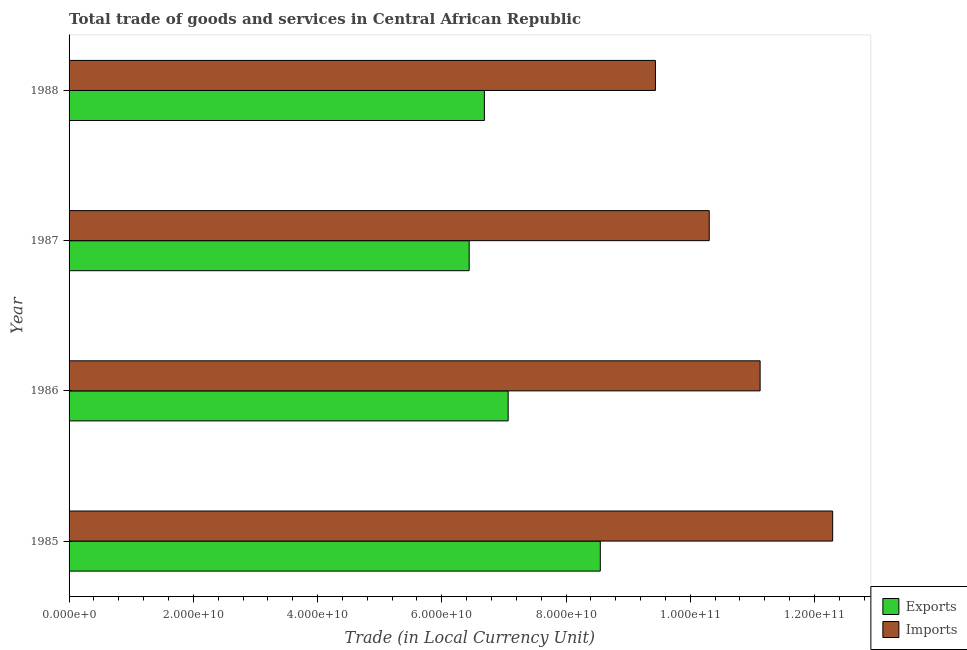How many different coloured bars are there?
Provide a short and direct response. 2. How many groups of bars are there?
Give a very brief answer. 4. How many bars are there on the 1st tick from the top?
Make the answer very short. 2. What is the label of the 1st group of bars from the top?
Your response must be concise. 1988. In how many cases, is the number of bars for a given year not equal to the number of legend labels?
Offer a very short reply. 0. What is the imports of goods and services in 1986?
Keep it short and to the point. 1.11e+11. Across all years, what is the maximum imports of goods and services?
Give a very brief answer. 1.23e+11. Across all years, what is the minimum export of goods and services?
Your response must be concise. 6.44e+1. In which year was the imports of goods and services minimum?
Your response must be concise. 1988. What is the total imports of goods and services in the graph?
Your answer should be compact. 4.32e+11. What is the difference between the imports of goods and services in 1985 and that in 1988?
Your answer should be very brief. 2.85e+1. What is the difference between the imports of goods and services in 1986 and the export of goods and services in 1985?
Provide a succinct answer. 2.57e+1. What is the average imports of goods and services per year?
Ensure brevity in your answer.  1.08e+11. In the year 1987, what is the difference between the export of goods and services and imports of goods and services?
Offer a terse response. -3.86e+1. In how many years, is the imports of goods and services greater than 24000000000 LCU?
Make the answer very short. 4. Is the export of goods and services in 1985 less than that in 1988?
Offer a terse response. No. What is the difference between the highest and the second highest imports of goods and services?
Your response must be concise. 1.17e+1. What is the difference between the highest and the lowest imports of goods and services?
Ensure brevity in your answer.  2.85e+1. In how many years, is the imports of goods and services greater than the average imports of goods and services taken over all years?
Your answer should be very brief. 2. What does the 1st bar from the top in 1987 represents?
Give a very brief answer. Imports. What does the 2nd bar from the bottom in 1988 represents?
Ensure brevity in your answer.  Imports. How many bars are there?
Your answer should be compact. 8. What is the difference between two consecutive major ticks on the X-axis?
Make the answer very short. 2.00e+1. Does the graph contain grids?
Offer a very short reply. No. How many legend labels are there?
Your response must be concise. 2. What is the title of the graph?
Keep it short and to the point. Total trade of goods and services in Central African Republic. Does "Lower secondary rate" appear as one of the legend labels in the graph?
Ensure brevity in your answer.  No. What is the label or title of the X-axis?
Give a very brief answer. Trade (in Local Currency Unit). What is the label or title of the Y-axis?
Your answer should be compact. Year. What is the Trade (in Local Currency Unit) of Exports in 1985?
Offer a terse response. 8.55e+1. What is the Trade (in Local Currency Unit) of Imports in 1985?
Provide a short and direct response. 1.23e+11. What is the Trade (in Local Currency Unit) in Exports in 1986?
Offer a very short reply. 7.07e+1. What is the Trade (in Local Currency Unit) of Imports in 1986?
Offer a very short reply. 1.11e+11. What is the Trade (in Local Currency Unit) of Exports in 1987?
Your answer should be very brief. 6.44e+1. What is the Trade (in Local Currency Unit) of Imports in 1987?
Offer a terse response. 1.03e+11. What is the Trade (in Local Currency Unit) in Exports in 1988?
Keep it short and to the point. 6.69e+1. What is the Trade (in Local Currency Unit) in Imports in 1988?
Make the answer very short. 9.44e+1. Across all years, what is the maximum Trade (in Local Currency Unit) in Exports?
Offer a terse response. 8.55e+1. Across all years, what is the maximum Trade (in Local Currency Unit) of Imports?
Give a very brief answer. 1.23e+11. Across all years, what is the minimum Trade (in Local Currency Unit) in Exports?
Offer a terse response. 6.44e+1. Across all years, what is the minimum Trade (in Local Currency Unit) of Imports?
Provide a short and direct response. 9.44e+1. What is the total Trade (in Local Currency Unit) in Exports in the graph?
Keep it short and to the point. 2.87e+11. What is the total Trade (in Local Currency Unit) of Imports in the graph?
Your answer should be compact. 4.32e+11. What is the difference between the Trade (in Local Currency Unit) of Exports in 1985 and that in 1986?
Offer a terse response. 1.48e+1. What is the difference between the Trade (in Local Currency Unit) in Imports in 1985 and that in 1986?
Your answer should be very brief. 1.17e+1. What is the difference between the Trade (in Local Currency Unit) in Exports in 1985 and that in 1987?
Make the answer very short. 2.11e+1. What is the difference between the Trade (in Local Currency Unit) in Imports in 1985 and that in 1987?
Give a very brief answer. 1.99e+1. What is the difference between the Trade (in Local Currency Unit) in Exports in 1985 and that in 1988?
Provide a succinct answer. 1.87e+1. What is the difference between the Trade (in Local Currency Unit) of Imports in 1985 and that in 1988?
Your answer should be very brief. 2.85e+1. What is the difference between the Trade (in Local Currency Unit) in Exports in 1986 and that in 1987?
Ensure brevity in your answer.  6.27e+09. What is the difference between the Trade (in Local Currency Unit) of Imports in 1986 and that in 1987?
Provide a succinct answer. 8.19e+09. What is the difference between the Trade (in Local Currency Unit) of Exports in 1986 and that in 1988?
Your answer should be very brief. 3.83e+09. What is the difference between the Trade (in Local Currency Unit) of Imports in 1986 and that in 1988?
Offer a very short reply. 1.69e+1. What is the difference between the Trade (in Local Currency Unit) of Exports in 1987 and that in 1988?
Give a very brief answer. -2.45e+09. What is the difference between the Trade (in Local Currency Unit) in Imports in 1987 and that in 1988?
Your answer should be very brief. 8.66e+09. What is the difference between the Trade (in Local Currency Unit) of Exports in 1985 and the Trade (in Local Currency Unit) of Imports in 1986?
Your answer should be compact. -2.57e+1. What is the difference between the Trade (in Local Currency Unit) of Exports in 1985 and the Trade (in Local Currency Unit) of Imports in 1987?
Keep it short and to the point. -1.75e+1. What is the difference between the Trade (in Local Currency Unit) of Exports in 1985 and the Trade (in Local Currency Unit) of Imports in 1988?
Your response must be concise. -8.88e+09. What is the difference between the Trade (in Local Currency Unit) of Exports in 1986 and the Trade (in Local Currency Unit) of Imports in 1987?
Give a very brief answer. -3.24e+1. What is the difference between the Trade (in Local Currency Unit) of Exports in 1986 and the Trade (in Local Currency Unit) of Imports in 1988?
Give a very brief answer. -2.37e+1. What is the difference between the Trade (in Local Currency Unit) in Exports in 1987 and the Trade (in Local Currency Unit) in Imports in 1988?
Ensure brevity in your answer.  -3.00e+1. What is the average Trade (in Local Currency Unit) in Exports per year?
Keep it short and to the point. 7.19e+1. What is the average Trade (in Local Currency Unit) in Imports per year?
Keep it short and to the point. 1.08e+11. In the year 1985, what is the difference between the Trade (in Local Currency Unit) of Exports and Trade (in Local Currency Unit) of Imports?
Provide a succinct answer. -3.74e+1. In the year 1986, what is the difference between the Trade (in Local Currency Unit) of Exports and Trade (in Local Currency Unit) of Imports?
Offer a very short reply. -4.06e+1. In the year 1987, what is the difference between the Trade (in Local Currency Unit) of Exports and Trade (in Local Currency Unit) of Imports?
Your response must be concise. -3.86e+1. In the year 1988, what is the difference between the Trade (in Local Currency Unit) in Exports and Trade (in Local Currency Unit) in Imports?
Keep it short and to the point. -2.75e+1. What is the ratio of the Trade (in Local Currency Unit) of Exports in 1985 to that in 1986?
Provide a succinct answer. 1.21. What is the ratio of the Trade (in Local Currency Unit) of Imports in 1985 to that in 1986?
Offer a very short reply. 1.1. What is the ratio of the Trade (in Local Currency Unit) of Exports in 1985 to that in 1987?
Your answer should be very brief. 1.33. What is the ratio of the Trade (in Local Currency Unit) of Imports in 1985 to that in 1987?
Your response must be concise. 1.19. What is the ratio of the Trade (in Local Currency Unit) in Exports in 1985 to that in 1988?
Offer a terse response. 1.28. What is the ratio of the Trade (in Local Currency Unit) in Imports in 1985 to that in 1988?
Provide a succinct answer. 1.3. What is the ratio of the Trade (in Local Currency Unit) of Exports in 1986 to that in 1987?
Give a very brief answer. 1.1. What is the ratio of the Trade (in Local Currency Unit) of Imports in 1986 to that in 1987?
Your answer should be very brief. 1.08. What is the ratio of the Trade (in Local Currency Unit) of Exports in 1986 to that in 1988?
Your answer should be compact. 1.06. What is the ratio of the Trade (in Local Currency Unit) in Imports in 1986 to that in 1988?
Give a very brief answer. 1.18. What is the ratio of the Trade (in Local Currency Unit) of Exports in 1987 to that in 1988?
Offer a terse response. 0.96. What is the ratio of the Trade (in Local Currency Unit) of Imports in 1987 to that in 1988?
Provide a succinct answer. 1.09. What is the difference between the highest and the second highest Trade (in Local Currency Unit) in Exports?
Your answer should be compact. 1.48e+1. What is the difference between the highest and the second highest Trade (in Local Currency Unit) in Imports?
Provide a succinct answer. 1.17e+1. What is the difference between the highest and the lowest Trade (in Local Currency Unit) of Exports?
Provide a short and direct response. 2.11e+1. What is the difference between the highest and the lowest Trade (in Local Currency Unit) in Imports?
Provide a succinct answer. 2.85e+1. 